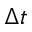<formula> <loc_0><loc_0><loc_500><loc_500>\Delta t</formula> 